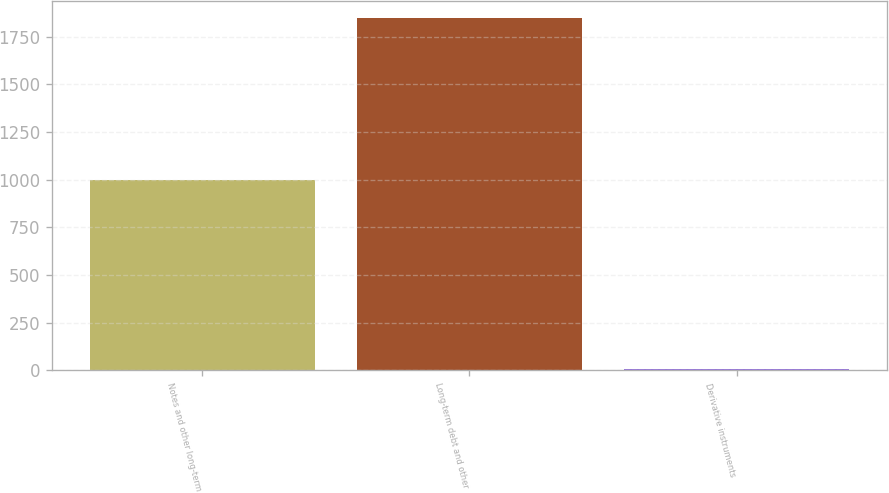<chart> <loc_0><loc_0><loc_500><loc_500><bar_chart><fcel>Notes and other long-term<fcel>Long-term debt and other<fcel>Derivative instruments<nl><fcel>996<fcel>1847<fcel>6<nl></chart> 